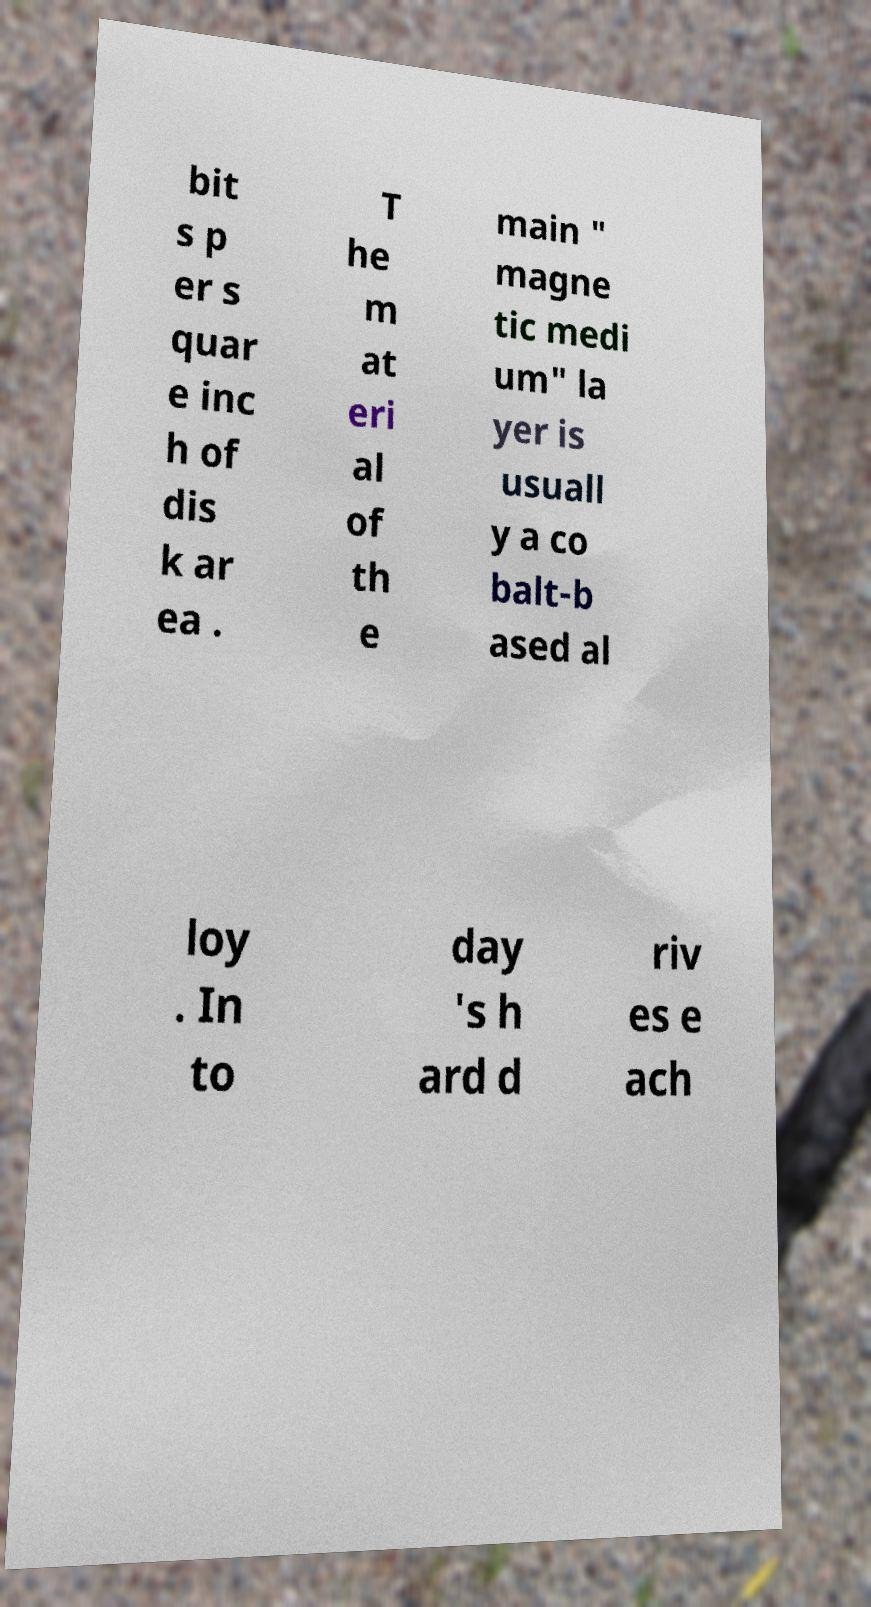There's text embedded in this image that I need extracted. Can you transcribe it verbatim? bit s p er s quar e inc h of dis k ar ea . T he m at eri al of th e main " magne tic medi um" la yer is usuall y a co balt-b ased al loy . In to day 's h ard d riv es e ach 